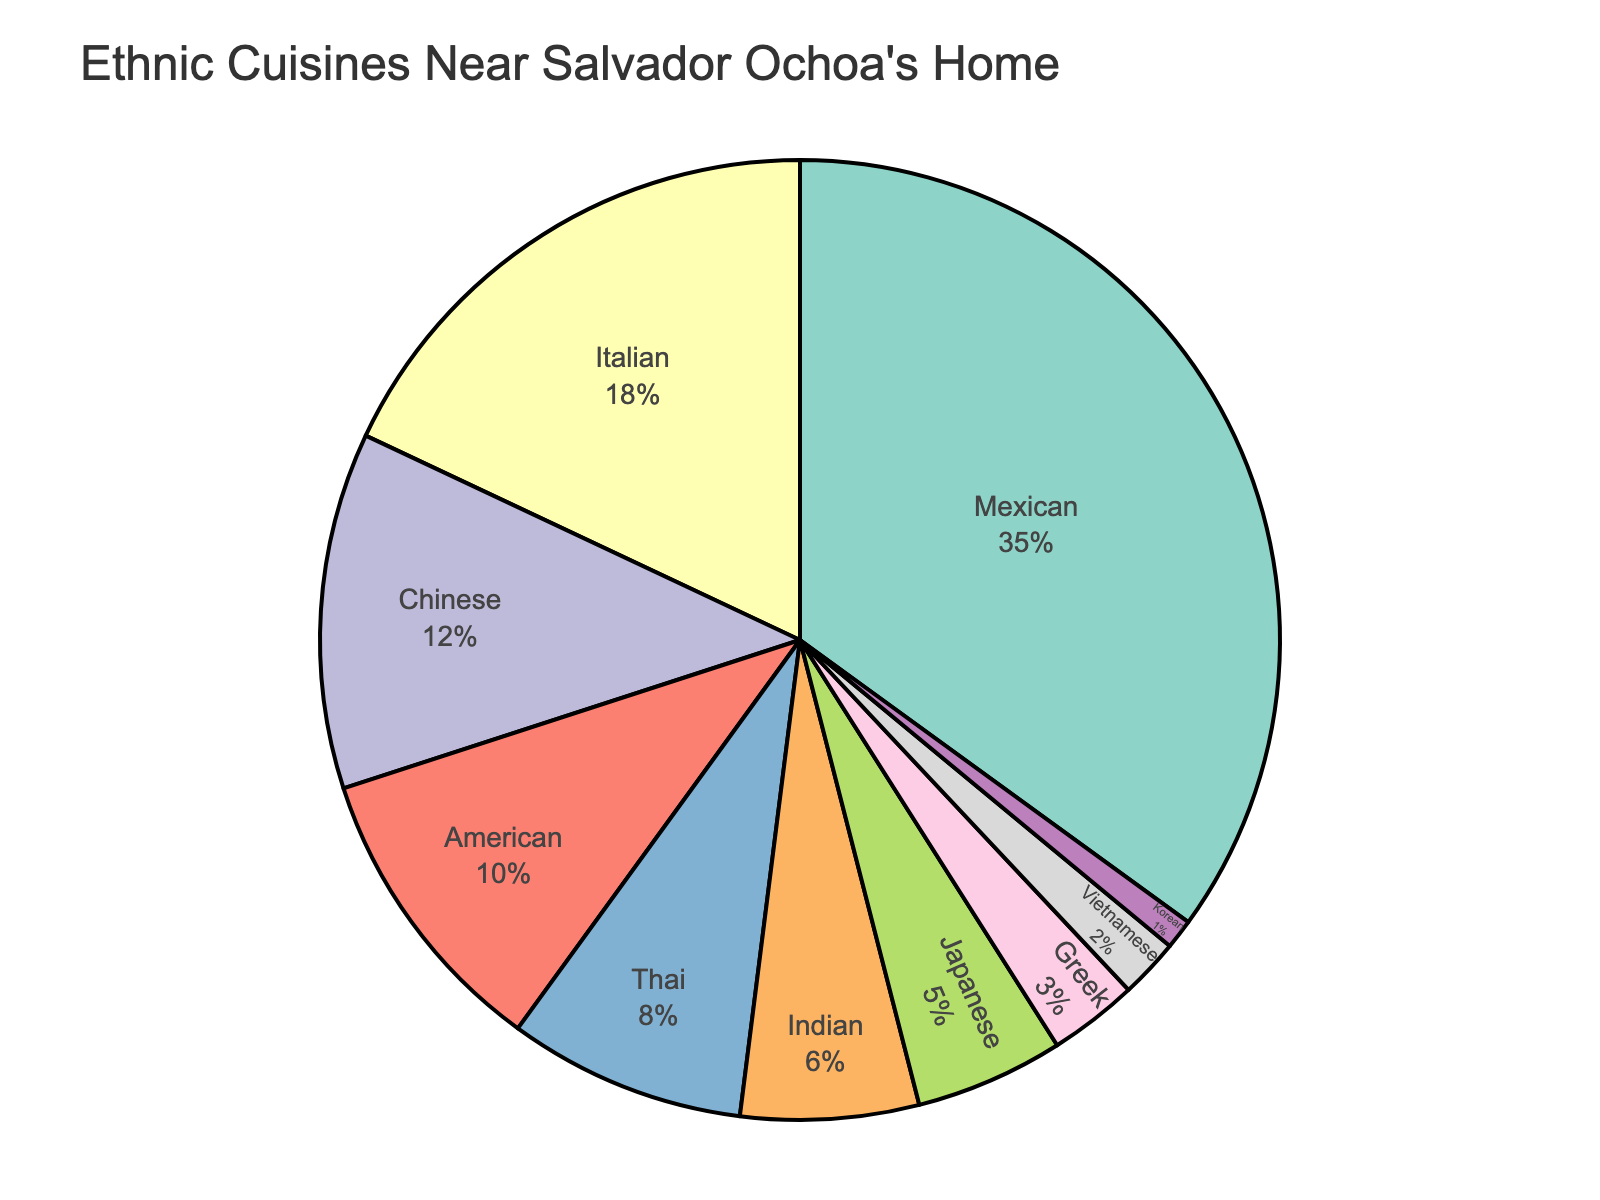What's the most popular ethnic cuisine available near Salvador Ochoa's home? The pie chart shows different ethnic cuisines and their corresponding percentages. By looking at the size of the segments, we can see that Mexican cuisine has the largest percentage.
Answer: Mexican Which ethnic cuisine has the smallest representation? The pie chart depicts various ethnic cuisines along with their percentage shares. The smallest segment belongs to Korean cuisine, which has the lowest percentage.
Answer: Korean How much greater is the percentage of Mexican cuisine compared to Greek cuisine? Mexican cuisine has a percentage of 35%, and Greek cuisine has 3%. The difference can be calculated by subtracting the percentage of Greek cuisine from Mexican cuisine (35% - 3% = 32%).
Answer: 32% Do Mexican and Italian cuisines combined represent more than 50% of the total cuisine types available? Mexican cuisine is 35% and Italian cuisine is 18%. Adding them together (35% + 18% = 53%) surpasses 50%. Thus, they combined represent more than 50%.
Answer: Yes Are there more restaurants offering Thai cuisine or American cuisine? By comparing the sizes of the segments for Thai cuisine (8%) and American cuisine (10%), it is clear that American cuisine has a higher percentage.
Answer: American What is the combined percentage of Asian cuisines (Chinese, Thai, Indian, Japanese, Vietnamese, Korean) available? The percentages for the Asian cuisines are as follows: Chinese 12%, Thai 8%, Indian 6%, Japanese 5%, Vietnamese 2%, Korean 1%. Summing these gives 12% + 8% + 6% + 5% + 2% + 1% = 34%.
Answer: 34% Which ethnic cuisine is more common, Chinese or Indian? Looking at the pie chart, Chinese cuisine has a percentage of 12%, while Indian cuisine is 6%. Therefore, Chinese cuisine is more common.
Answer: Chinese How does the percentage of Mexican cuisine compare to the combined percentage of Japanese and Greek cuisines? The percentage for Mexican cuisine is 35%. Combined, Japanese is 5% and Greek is 3%, giving a total of 8%. Thus, Mexican cuisine is significantly higher (35% compared to 8%).
Answer: Mexican is higher What percentage of the cuisines fall below 10%? The cuisines under 10% are Chinese (12%), Thai (8%), Indian (6%), Japanese (5%), Greek (3%), Vietnamese (2%), Korean (1%). Summing these gives 8% + 6% + 5% + 3% + 2% + 1% = 30%.
Answer: 30% Is there any cuisine whose representation is exactly double another, and if so, which ones? By examining the percentages, Italian cuisine (18%) and Mexican cuisine (35%) do not have exact doubles. However, American cuisine (10%) is exactly double that of Indian cuisine (5%).
Answer: American and Indian 